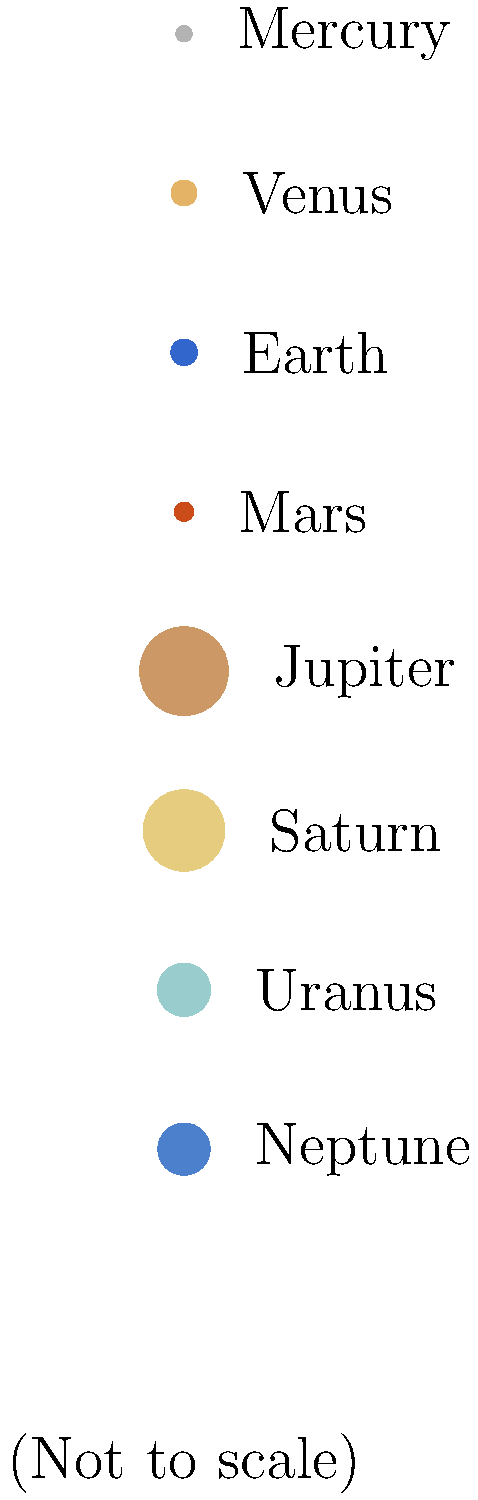In this scaled diagram of our solar system, the size of each planet is represented by the area of its circle. The actual diameters of Earth and Jupiter are 12,742 km and 139,820 km, respectively. Approximately how many times larger is Jupiter's volume compared to Earth's? Let's approach this step-by-step:

1) First, we need to understand that the volume of a sphere is proportional to the cube of its diameter. The formula for the volume of a sphere is $V = \frac{4}{3}\pi r^3$, where $r$ is the radius (half the diameter).

2) Let's call Earth's diameter $d_E$ and Jupiter's diameter $d_J$. We're given:
   $d_E = 12,742$ km
   $d_J = 139,820$ km

3) The ratio of their volumes will be:

   $\frac{V_J}{V_E} = \frac{\frac{4}{3}\pi (\frac{d_J}{2})^3}{\frac{4}{3}\pi (\frac{d_E}{2})^3} = (\frac{d_J}{d_E})^3$

4) Let's calculate this ratio:

   $(\frac{139,820}{12,742})^3 = 10.97^3 \approx 1,321$

5) This means Jupiter's volume is approximately 1,321 times larger than Earth's.

To verify this, we can look at the areas of the circles in the diagram. Jupiter's circle area is about 11.25 times larger than Earth's (142.9 / 12.7), which corresponds to a volume about 1,300 times larger, confirming our calculation.
Answer: Approximately 1,321 times 